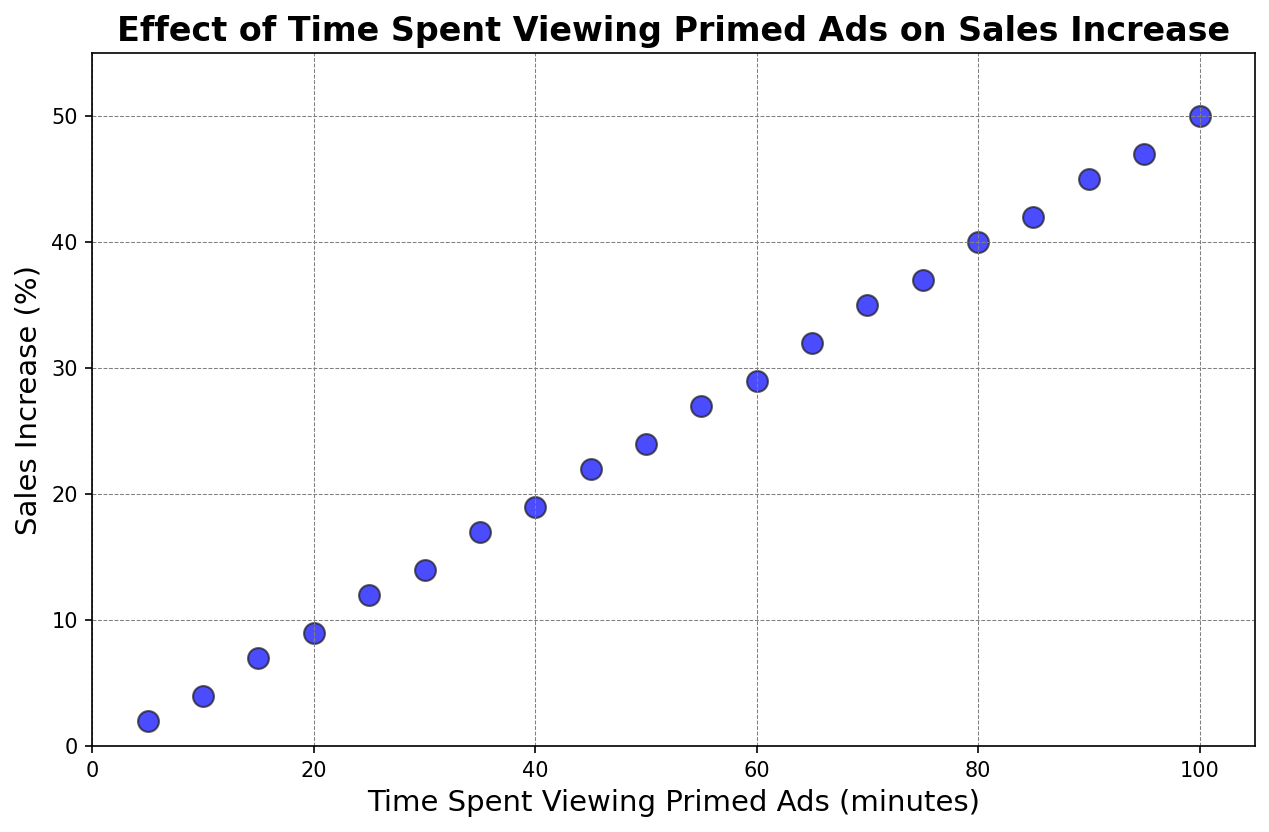What's the maximum sales increase observed? To find the maximum sales increase, look at the highest value on the y-axis (Sales Increase). The highest point on the scatter plot is at 50%.
Answer: 50 What is the sales increase when the time spent viewing primed ads is 60 minutes? Look at the point on the x-axis where the time spent viewing primed ads is 60 minutes. The corresponding y-axis value (Sales Increase) at this point is 29%.
Answer: 29 What is the average sales increase when the time spent viewing primed ads is between 40 and 60 minutes? Identify the sales increases for 40, 45, 50, 55, and 60 minutes: 19%, 22%, 24%, 27%, and 29%. Sum these values and divide by the number of data points (5). (19 + 22 + 24 + 27 + 29) / 5 = 121 / 5 = 24.2%
Answer: 24.2 Compare the sales increase at 25 minutes and 75 minutes. Which one has a higher sales increase and by how much? For 25 minutes, the sales increase is 12%. For 75 minutes, the sales increase is 37%. Subtract 12% from 37% to find the difference (37 - 12). 75 minutes has a higher sales increase by (37 - 12 =) 25%.
Answer: 75 minutes has a higher sales increase by 25% What is the trend observed between the time spent viewing primed ads and the sales increase? Examine the overall pattern of the points on the scatter plot. As the time spent viewing primed ads increases, the sales increase also tends to increase, showing a positive correlation.
Answer: Positive correlation Which time interval shows a jump of 5% in sales increase? Check the intervals for a jump of 5%. Between 40 minutes (19%) and 45 minutes (22%), there is a jump of 3%. Check other intervals until you find a jump of 5%, which is from 10 minutes (4%) to 15 minutes (7%).
Answer: 10 to 15 minutes Estimate the sales increase if the time spent viewing primed ads increases by 10 minutes from 50 minutes. The sales increase at 50 minutes is 24%. The typical increase per 10 minutes (judged by the pattern) appears to be around 3%. Adding 3% to 24%, we get approximately 27%.
Answer: Approximately 27% At what time spent viewing primed ads does the sales increase first reach 20%? Look at the scatter plot and identify when the y-axis value first hits 20%. It is between 40 and 45 minutes but is closest at 45 minutes (where it is actually 22%).
Answer: 45 minutes What is the median sales increase for time spent viewing primed ads from 5 to 100 minutes? Identify all the sales increases and order them: 2, 4, 7, 9, 12, 14, 17, 19, 22, 24, 27, 29, 32, 35, 37, 40, 42, 45, 47, 50. The median is the middle value of the ordered list, which for 20 values is the average of the 10th and 11th values: (24 + 27) / 2 = 25.5%.
Answer: 25.5 